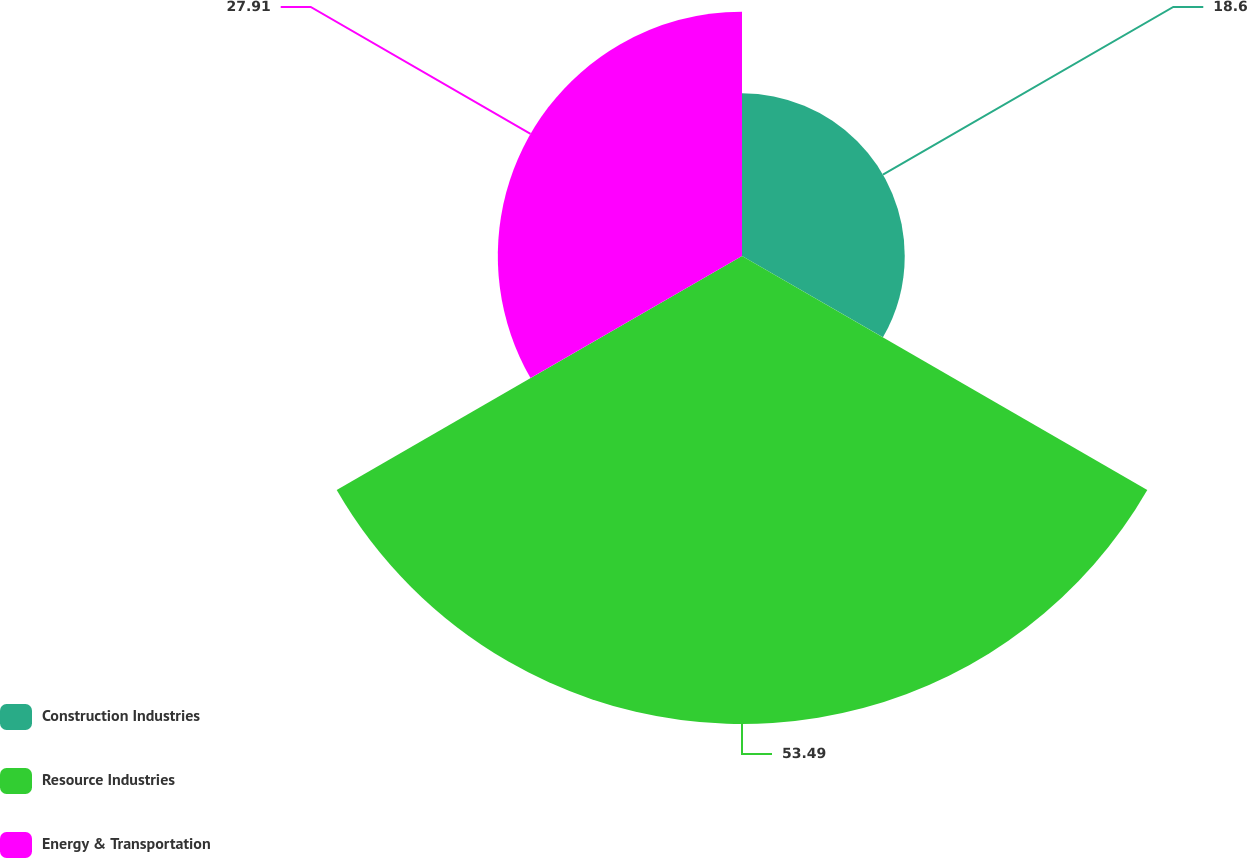Convert chart to OTSL. <chart><loc_0><loc_0><loc_500><loc_500><pie_chart><fcel>Construction Industries<fcel>Resource Industries<fcel>Energy & Transportation<nl><fcel>18.6%<fcel>53.49%<fcel>27.91%<nl></chart> 